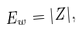Convert formula to latex. <formula><loc_0><loc_0><loc_500><loc_500>E _ { w } = | Z | ,</formula> 